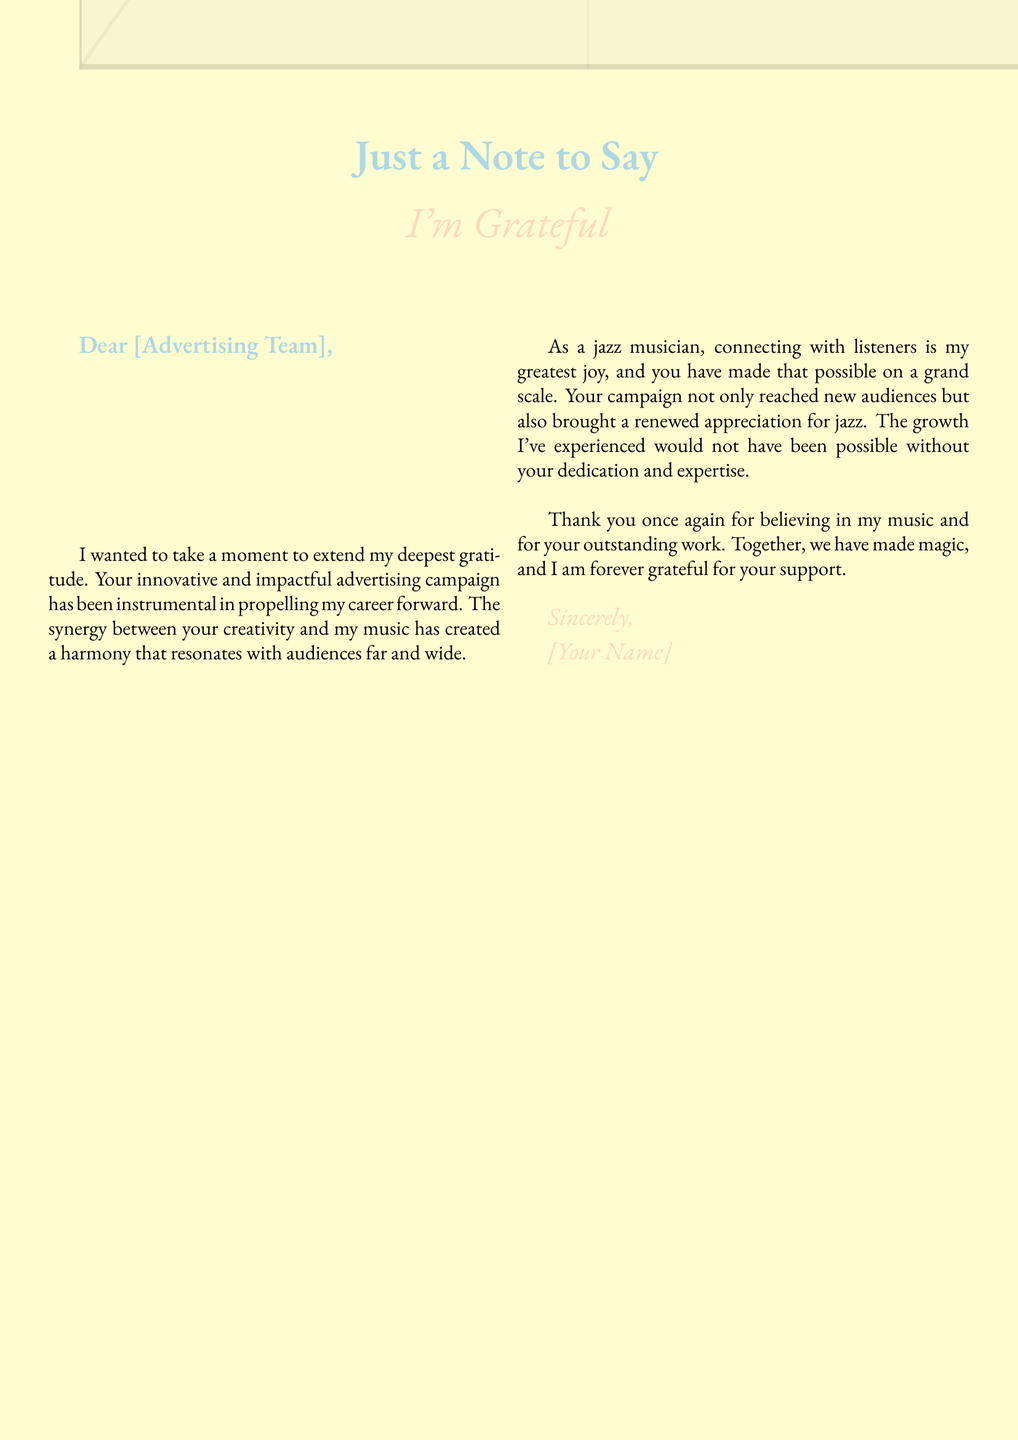What is the title of the card? The title of the card is prominently displayed at the top, stating "Just a Note to Say."
Answer: Just a Note to Say What color palette is used in the card? The document describes a "soft color palette", indicating the use of soft colors throughout.
Answer: Soft color palette Who is the card addressed to? The opening salutation indicates that the card is addressed to the "Advertising Team."
Answer: Advertising Team What profession does the sender identify as? The sender describes themselves as a "jazz musician."
Answer: Jazz musician What does the sender express gratitude for? The sender expresses gratitude for the "innovative and impactful advertising campaign."
Answer: Innovative and impactful advertising campaign What is one effect of the campaign mentioned by the sender? The sender notes that the campaign has "been instrumental in propelling my career forward."
Answer: Propelling my career forward How does the sender describe their connection with listeners? The sender states that "connecting with listeners is my greatest joy."
Answer: My greatest joy What is the concluding phrase used by the sender? The card concludes with the phrase "Thank you once again for believing in my music."
Answer: Thank you once again for believing in my music What does the color cream signify in the document? The color cream is used as the background color, contributing to the overall elegant design of the card.
Answer: Elegant design 